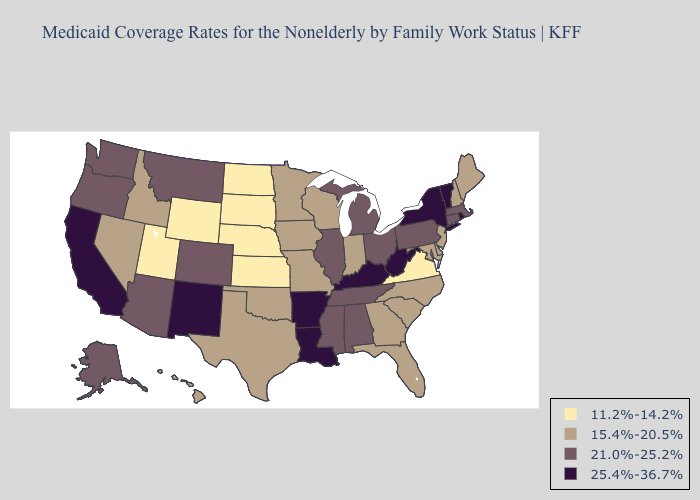What is the highest value in states that border Tennessee?
Keep it brief. 25.4%-36.7%. Name the states that have a value in the range 15.4%-20.5%?
Answer briefly. Delaware, Florida, Georgia, Hawaii, Idaho, Indiana, Iowa, Maine, Maryland, Minnesota, Missouri, Nevada, New Hampshire, New Jersey, North Carolina, Oklahoma, South Carolina, Texas, Wisconsin. What is the highest value in states that border Oregon?
Be succinct. 25.4%-36.7%. Name the states that have a value in the range 25.4%-36.7%?
Short answer required. Arkansas, California, Kentucky, Louisiana, New Mexico, New York, Rhode Island, Vermont, West Virginia. Does Virginia have the lowest value in the USA?
Keep it brief. Yes. What is the value of Hawaii?
Concise answer only. 15.4%-20.5%. Does the map have missing data?
Quick response, please. No. Which states have the lowest value in the USA?
Short answer required. Kansas, Nebraska, North Dakota, South Dakota, Utah, Virginia, Wyoming. Name the states that have a value in the range 21.0%-25.2%?
Keep it brief. Alabama, Alaska, Arizona, Colorado, Connecticut, Illinois, Massachusetts, Michigan, Mississippi, Montana, Ohio, Oregon, Pennsylvania, Tennessee, Washington. What is the value of Wisconsin?
Give a very brief answer. 15.4%-20.5%. What is the highest value in states that border Nevada?
Be succinct. 25.4%-36.7%. Which states have the lowest value in the USA?
Write a very short answer. Kansas, Nebraska, North Dakota, South Dakota, Utah, Virginia, Wyoming. Name the states that have a value in the range 15.4%-20.5%?
Keep it brief. Delaware, Florida, Georgia, Hawaii, Idaho, Indiana, Iowa, Maine, Maryland, Minnesota, Missouri, Nevada, New Hampshire, New Jersey, North Carolina, Oklahoma, South Carolina, Texas, Wisconsin. How many symbols are there in the legend?
Short answer required. 4. Which states have the lowest value in the West?
Short answer required. Utah, Wyoming. 